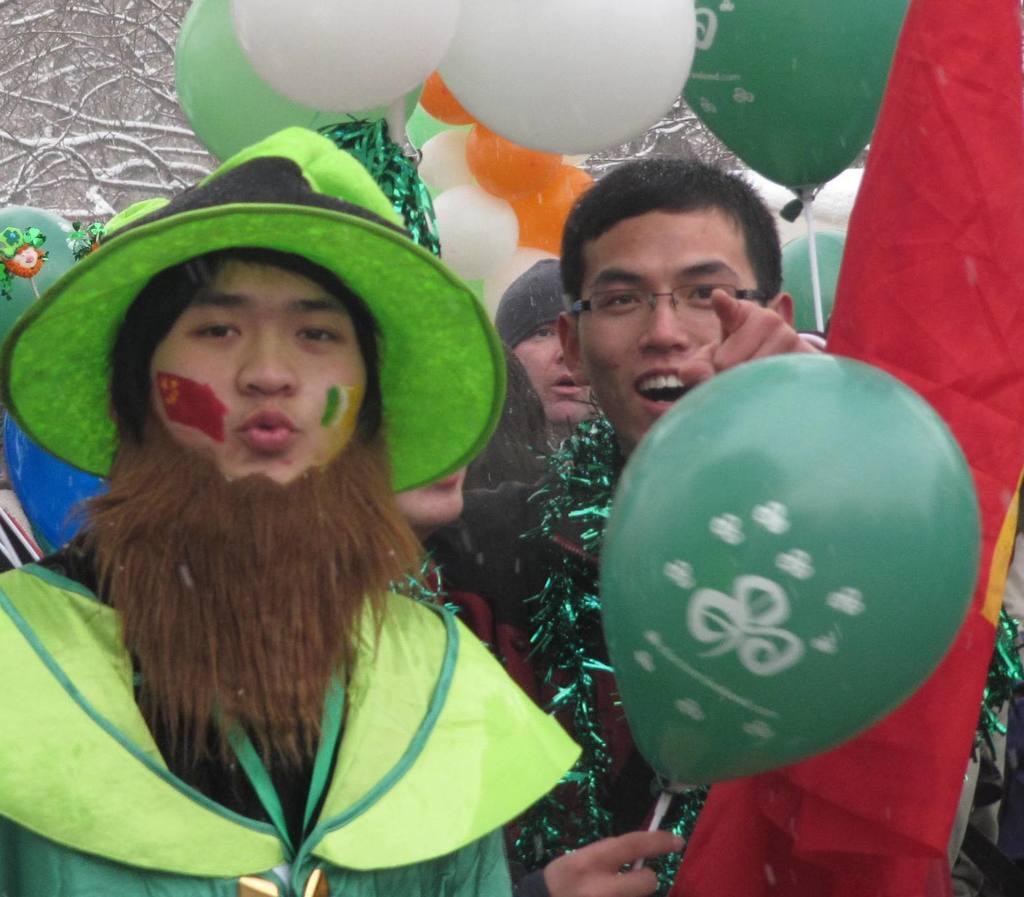Please provide a concise description of this image. On the left side of the image there is a person wearing a costume, cap on the head and looking at the picture. Beside him there is another person also looking at the picture and pointing out at the picture. He is holding a balloon in the hand. In the background, I can see some more people and few balloons. On the right side there is a red color flag. 